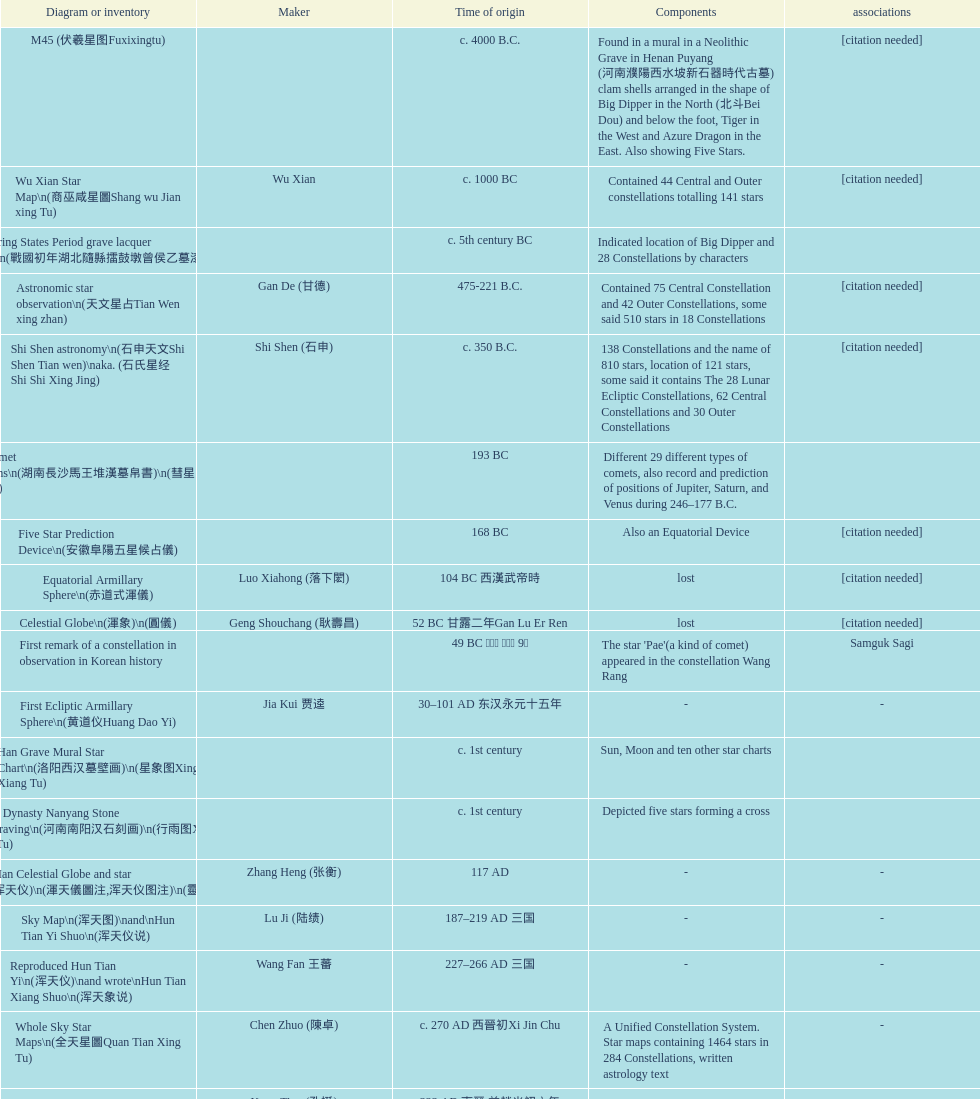Which was the first chinese star map known to have been created? M45 (伏羲星图Fuxixingtu). 